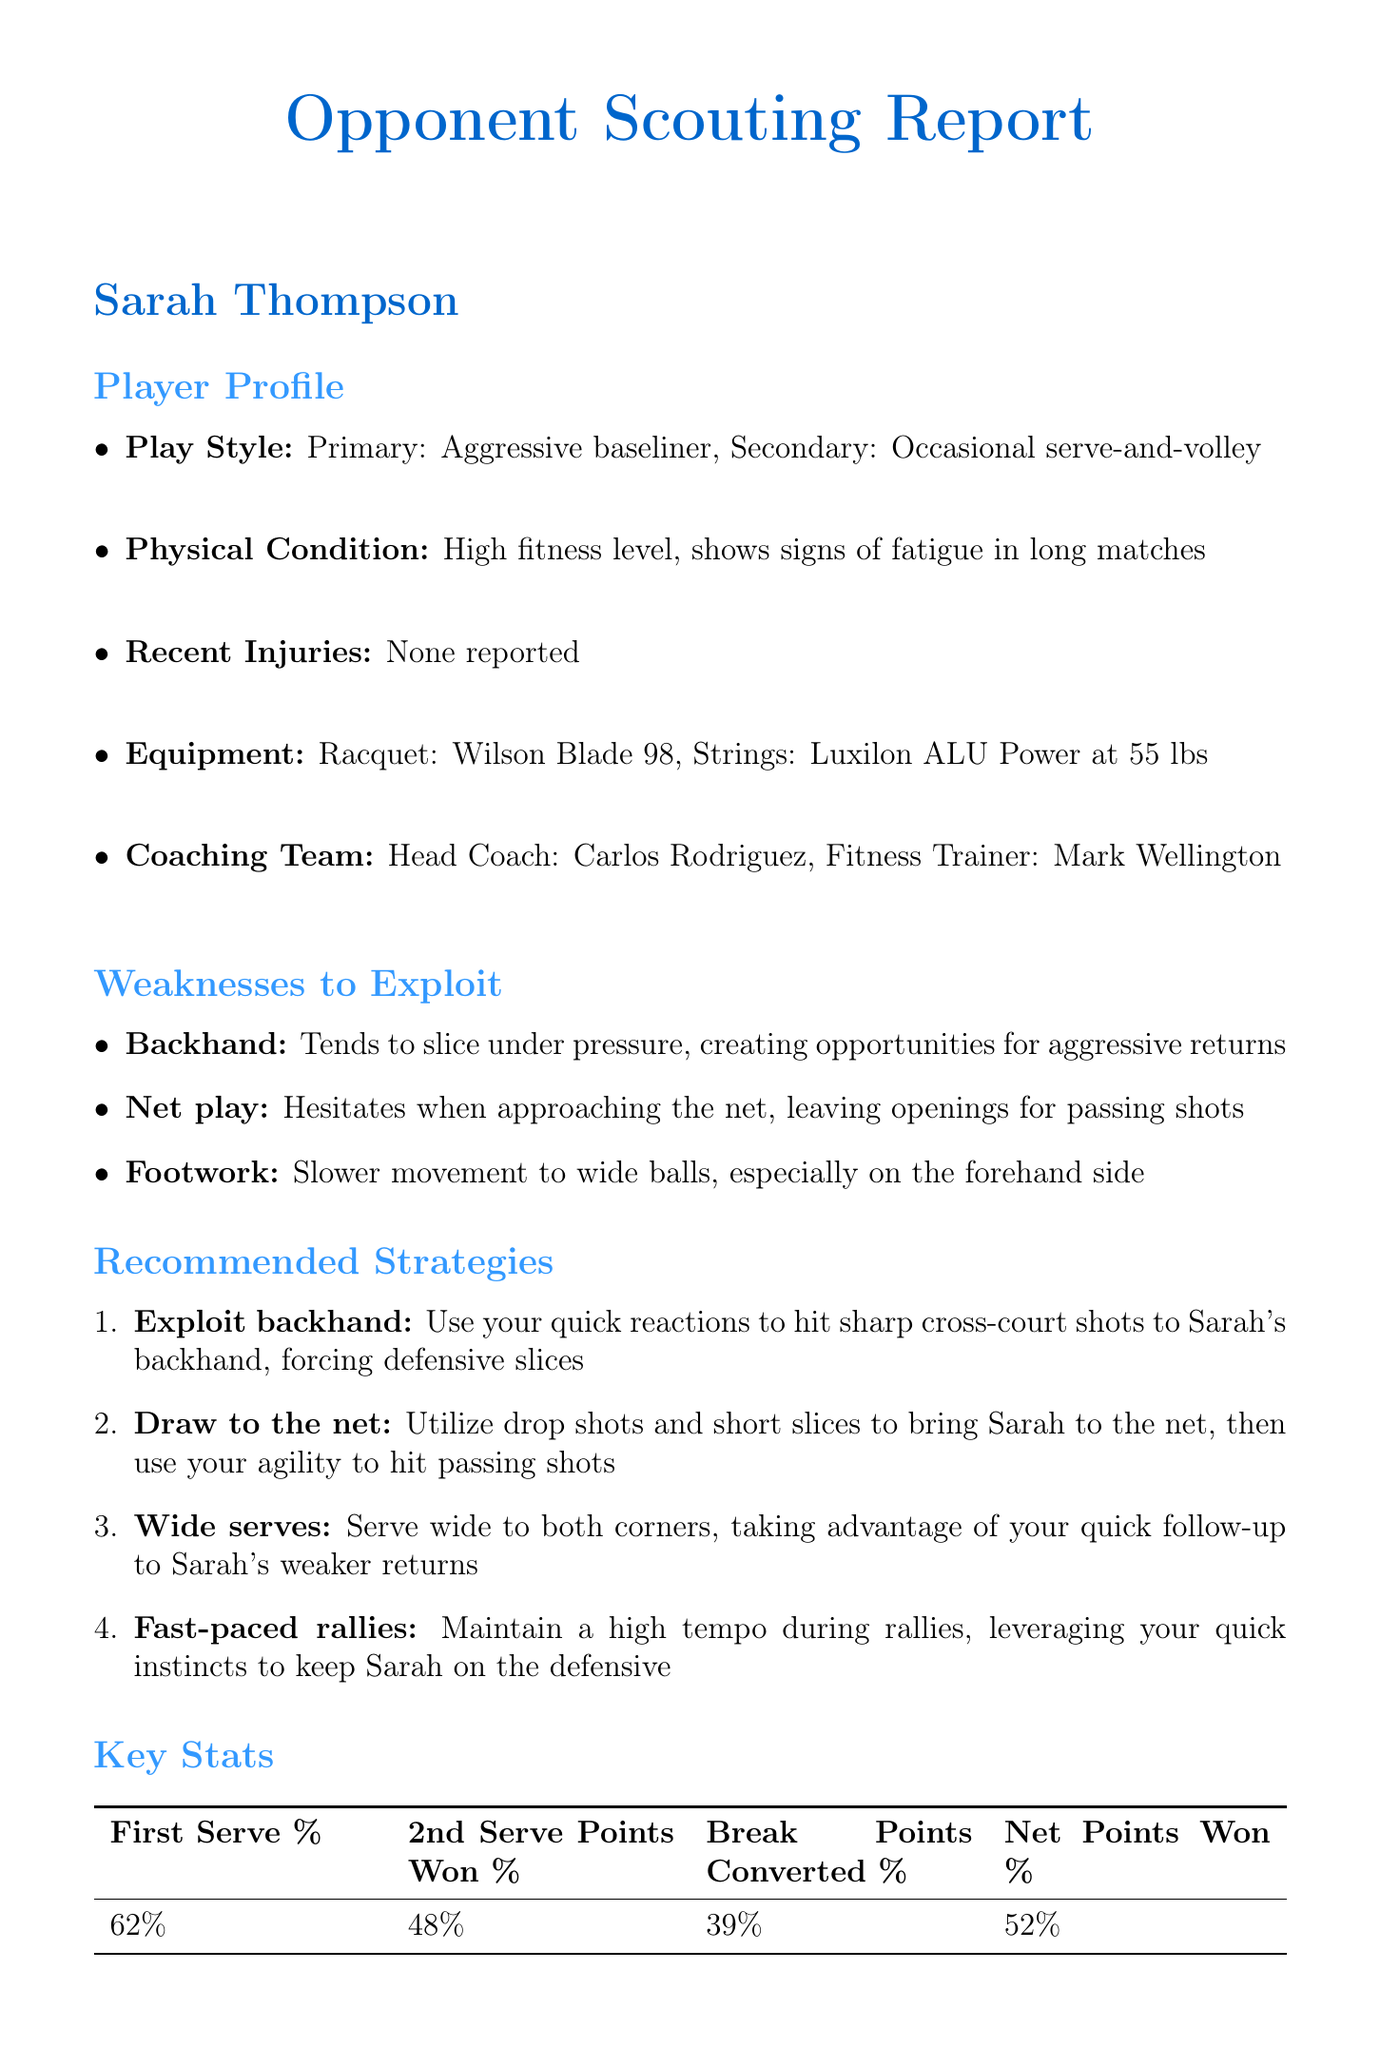What is the primary play style of Sarah Thompson? The primary play style of Sarah Thompson is mentioned in the player profile as "Aggressive baseliner."
Answer: Aggressive baseliner What weakness does Sarah have in her backhand? The document states that she "tends to slice under pressure, creating opportunities for aggressive returns."
Answer: Slices under pressure What percentages are given for Sarah's first serve? The document provides a specific statistic related to her serves, indicating it as "62%."
Answer: 62% Which tournament did Sarah reach the quarter-finals? The recent performance section reveals Sarah's result at the French Open as "Quarter-finals."
Answer: French Open What is one mental weakness of Sarah Thompson? The document lists one of her mental weaknesses as "Can become frustrated when opponent changes pace frequently."
Answer: Frustrated with pace changes What strategy involves using drop shots? The recommended strategies outline that "Utilize drop shots" is part of the strategy to draw her to the net.
Answer: Draw to the net How many break points did Sarah convert according to the key stats? The key stats section states that Sarah's "break points converted" percentage is "39%."
Answer: 39% Who is Sarah's head coach? The document identifies her head coach as "Carlos Rodriguez."
Answer: Carlos Rodriguez 